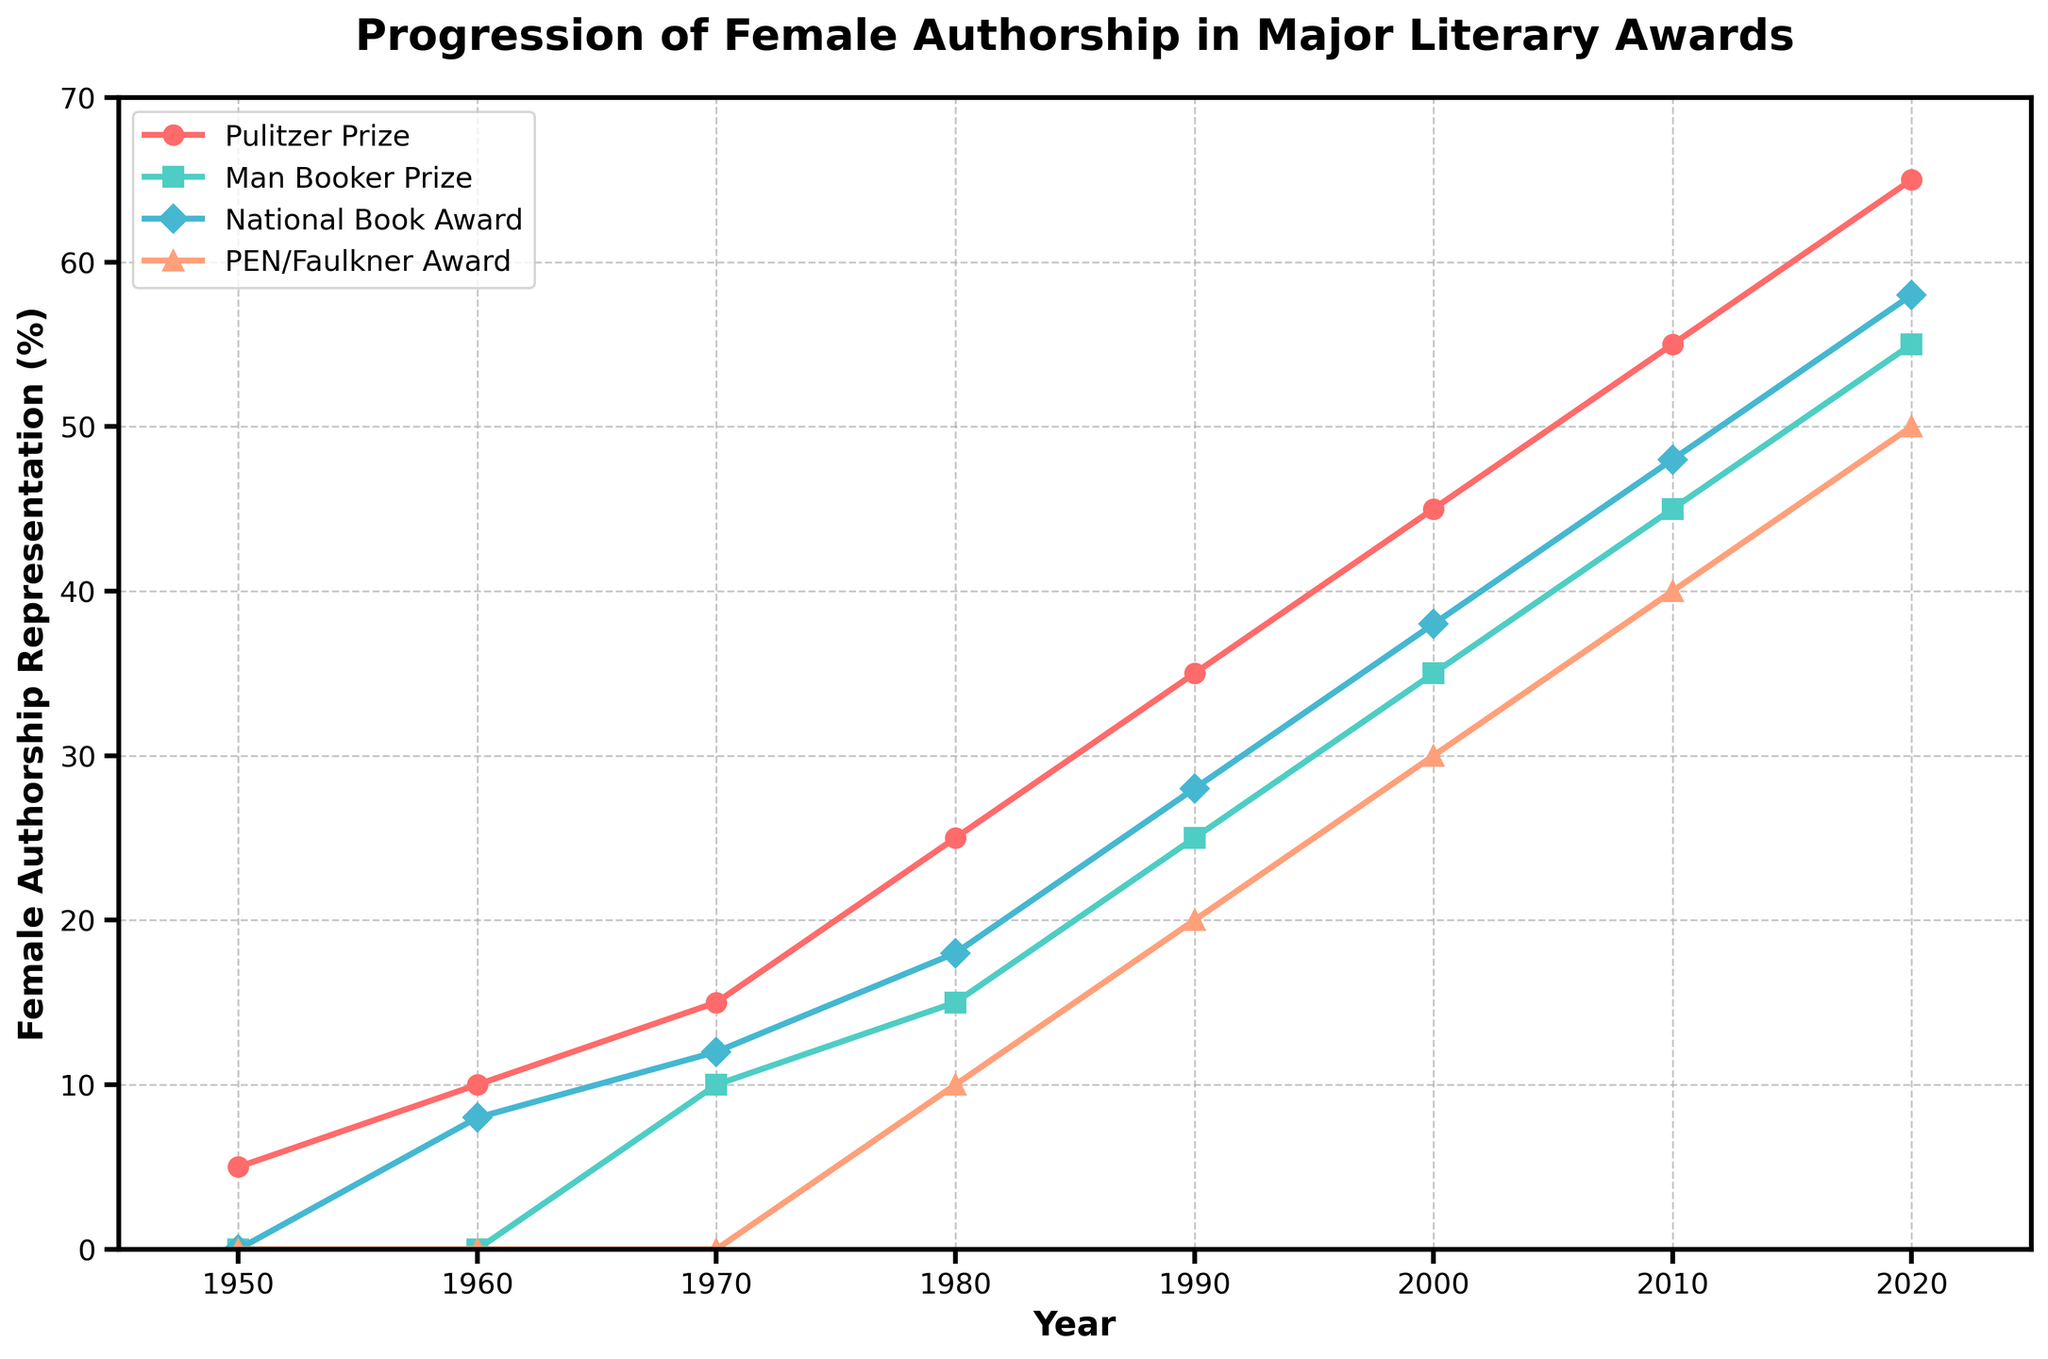What general trend can you observe for the Pulitzer Prize from 1950 to 2020? The Pulitzer Prize shows a consistent upward trend, starting at 5% in 1950 and progressing to 65% in 2020.
Answer: Consistent upward trend Did female authorship representation grow faster for the PEN/Faulkner Award or the National Book Award between 1980 and 2000? In 1980, the PEN/Faulkner Award was at 10%, growing to 30% in 2000, an increase of 20%. The National Book Award grew from 18% in 1980 to 38% in 2000, an increase of 20% as well. Both awards had the same growth rate.
Answer: Both awards had the same growth rate Which award had the highest female authorship representation in 2020 and what was the percentage? In 2020, the Pulitzer Prize had the highest female authorship representation at 65%.
Answer: Pulitzer Prize, 65% How much did the female authorship representation for the Man Booker Prize increase from 1970 to 2010? The representation increased from 10% in 1970 to 45% in 2010. The difference is 45% - 10% = 35%.
Answer: 35% Was there any literary award that had no female authorship representation in its early years? Yes, the National Book Award and the PEN/Faulkner Award both had 0% female authorship representation in 1950 and 1960.
Answer: National Book Award, PEN/Faulkner Award Which award had the smallest increase in female authorship representation from 1980 to 2020? For the Pulitzer Prize, the increase was from 25% to 65% (+40%). For the Man Booker Prize, it was from 15% to 55% (+40%). For the National Book Award, it was from 18% to 58% (+40%). For the PEN/Faulkner Award, it was from 10% to 50% (+40%). All awards had the same increase.
Answer: All awards had the same increase How did the representation for female authorship in the Pulitzer Prize in 1960 compare with that in the National Book Award in 2010? In 1960, the Pulitzer Prize had a representation of 10%, whereas the National Book Award had a representation of 48% in 2010. The National Book Award in 2010 was higher by 48% - 10% = 38%.
Answer: The National Book Award in 2010 was higher by 38% What's the average female authorship representation for the Man Booker Prize over the decades shown? The data points for the Man Booker Prize are 0%, 0%, 10%, 15%, 25%, 35%, 45%, 55%. Adding them yields 185. To find the average: 185/8 = 23.125%.
Answer: 23.125% Which decade saw the highest increase in female authorship representation for the PEN/Faulkner Award? From 1980 to 1990, the PEN/Faulkner Award increased from 10% to 20% (+10%). From 1990 to 2000, it increased from 20% to 30% (+10%). From 2000 to 2010, it increased from 30% to 40% (+10%). From 2010 to 2020, it increased from 40% to 50% (+10%). All decades had the same increase.
Answer: All decades had the same increase 